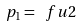<formula> <loc_0><loc_0><loc_500><loc_500>p _ { 1 } = \ f { u } { 2 }</formula> 